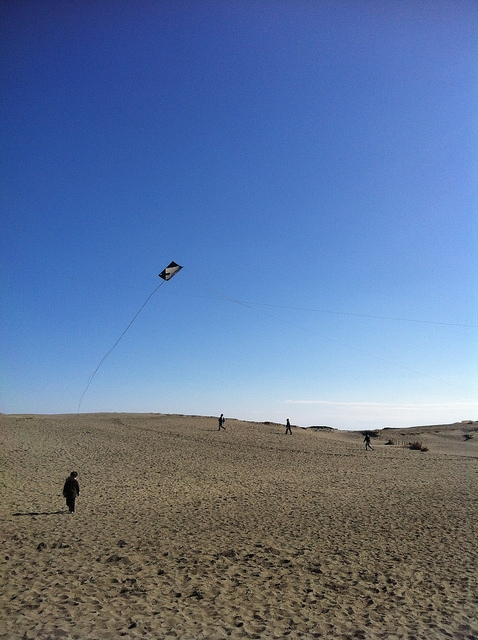<image>Where is a bridge? There is no bridge in the image. What is the dog holding? The dog is not holding anything in the image. However, it can be a frisbee, ball, kite or bone. Why are there clouds on the horizon? It is unknown why there are clouds on the horizon. There may not be any clouds. What kind of formations are sticking out of the sand? I don't know what kind of formations are sticking out of the sand. Where is a bridge? I don't know where a bridge is. It can be usually placed over water or somewhere off camera. What is the dog holding? I don't know what the dog is holding. It can be seen holding nothing, a frisbee, a ball, a kite, or a bone. Why are there clouds on the horizon? I don't know why there are clouds on the horizon. It could be because it is going to rain or it is part of the water cycle. What kind of formations are sticking out of the sand? I don't know what kind of formations are sticking out of the sand. It can be seen footprints, wave, people, mounds, dunes, ripples or hills. 